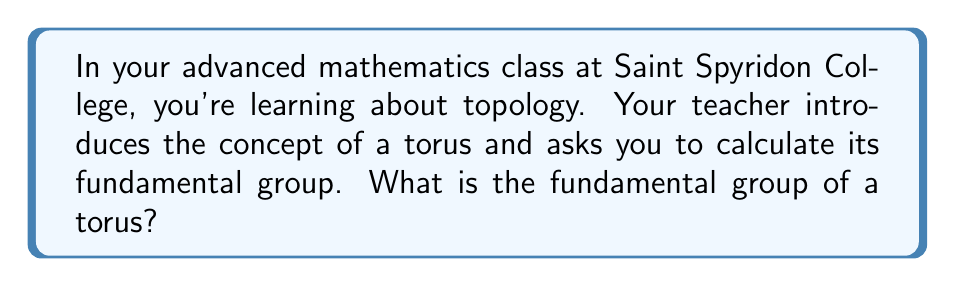Give your solution to this math problem. To calculate the fundamental group of a torus, we need to follow these steps:

1) First, recall that a torus is a surface that can be visualized as a donut shape. It has two distinct cycles: one around the "tube" and one through the "hole".

2) In topology, we represent the torus as a square with its edges identified in pairs:

[asy]
unitsize(1cm);
draw((-2,-2)--(2,-2)--(2,2)--(-2,2)--cycle);
draw((-2,-2)--(-1.8,-2),arrow=Arrow(TeXHead));
draw((2,-2)--(1.8,-2),arrow=Arrow(TeXHead));
draw((-2,-2)--(-2,-1.8),arrow=Arrow(TeXHead));
draw((-2,2)--(-2,1.8),arrow=Arrow(TeXHead));
label("a", (0,-2), S);
label("a", (0,2), N);
label("b", (-2,0), W);
label("b", (2,0), E);
[/asy]

3) The fundamental group of a space consists of equivalence classes of loops in the space, where two loops are equivalent if one can be continuously deformed into the other.

4) For the torus, we have two generating loops: one horizontal (let's call it $a$) and one vertical (let's call it $b$). These loops cannot be deformed into each other or into a point.

5) Any loop on the torus can be represented as a combination of these two loops. For example, going around the tube once and through the hole twice would be represented as $abb$.

6) The key property of the torus is that these loops commute: $ab = ba$. This is because we can slide the horizontal loop up or down, and the vertical loop left or right, without changing the overall path.

7) Therefore, the fundamental group of the torus is the free abelian group on two generators. In group theory notation, this is written as:

   $$\pi_1(T) \cong \mathbb{Z} \times \mathbb{Z}$$

   where $\mathbb{Z}$ is the group of integers under addition.

This group represents all possible combinations of the two generating loops, where the order of combination doesn't matter (abelian property).
Answer: $$\pi_1(T) \cong \mathbb{Z} \times \mathbb{Z}$$ 